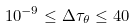<formula> <loc_0><loc_0><loc_500><loc_500>1 0 ^ { - 9 } \leq \Delta \tau _ { \theta } \leq 4 0</formula> 